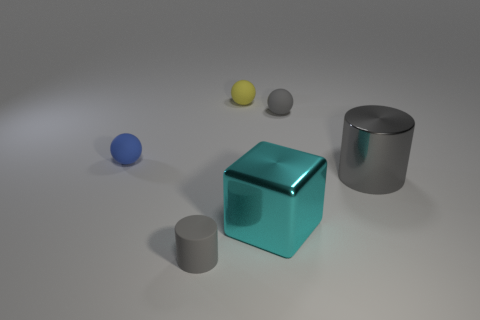Subtract all blue balls. How many balls are left? 2 Subtract all small gray spheres. How many spheres are left? 2 Subtract 2 cylinders. How many cylinders are left? 0 Subtract all purple cylinders. Subtract all red cubes. How many cylinders are left? 2 Subtract all green cubes. How many blue spheres are left? 1 Subtract all tiny purple blocks. Subtract all yellow matte balls. How many objects are left? 5 Add 3 small rubber cylinders. How many small rubber cylinders are left? 4 Add 5 small gray rubber objects. How many small gray rubber objects exist? 7 Add 2 tiny yellow matte spheres. How many objects exist? 8 Subtract 0 red cylinders. How many objects are left? 6 